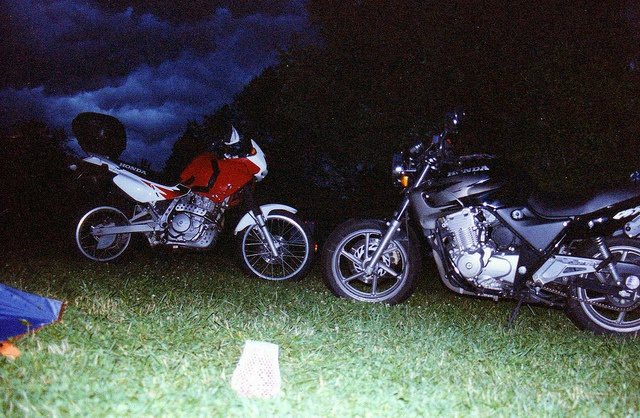Describe the objects in this image and their specific colors. I can see motorcycle in navy, black, gray, and purple tones and motorcycle in navy, black, maroon, and gray tones in this image. 